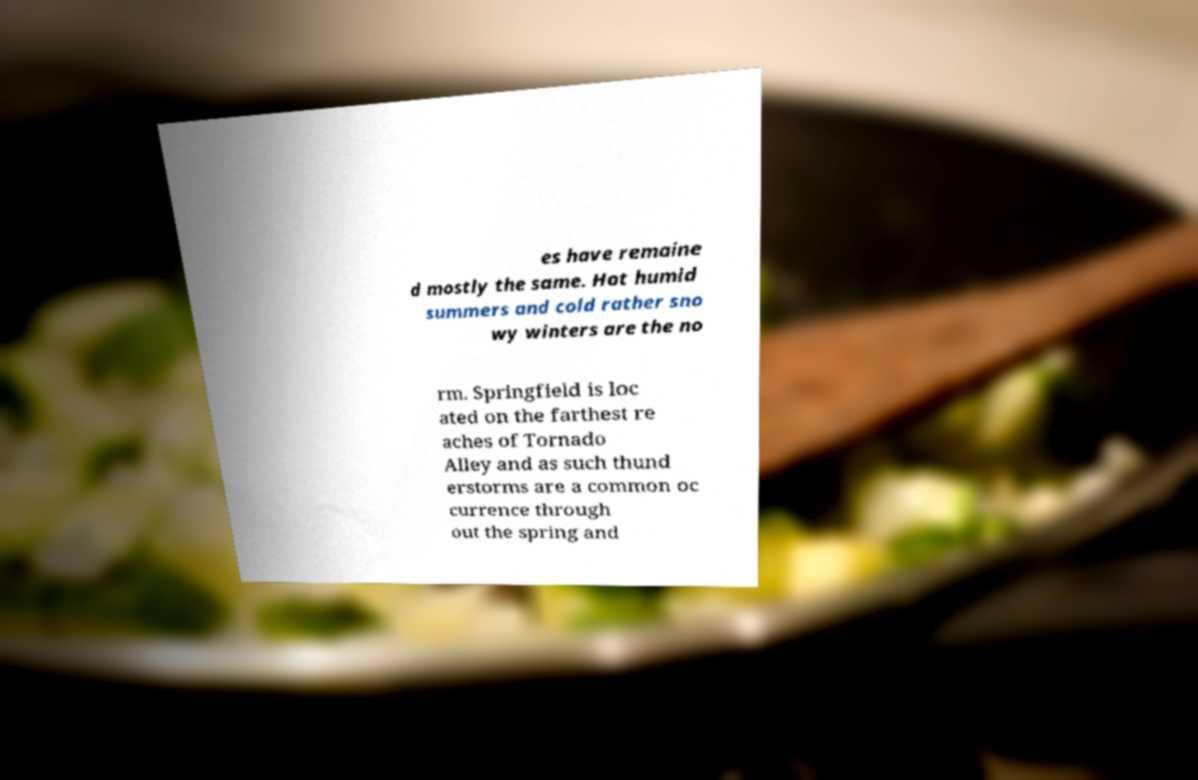For documentation purposes, I need the text within this image transcribed. Could you provide that? es have remaine d mostly the same. Hot humid summers and cold rather sno wy winters are the no rm. Springfield is loc ated on the farthest re aches of Tornado Alley and as such thund erstorms are a common oc currence through out the spring and 